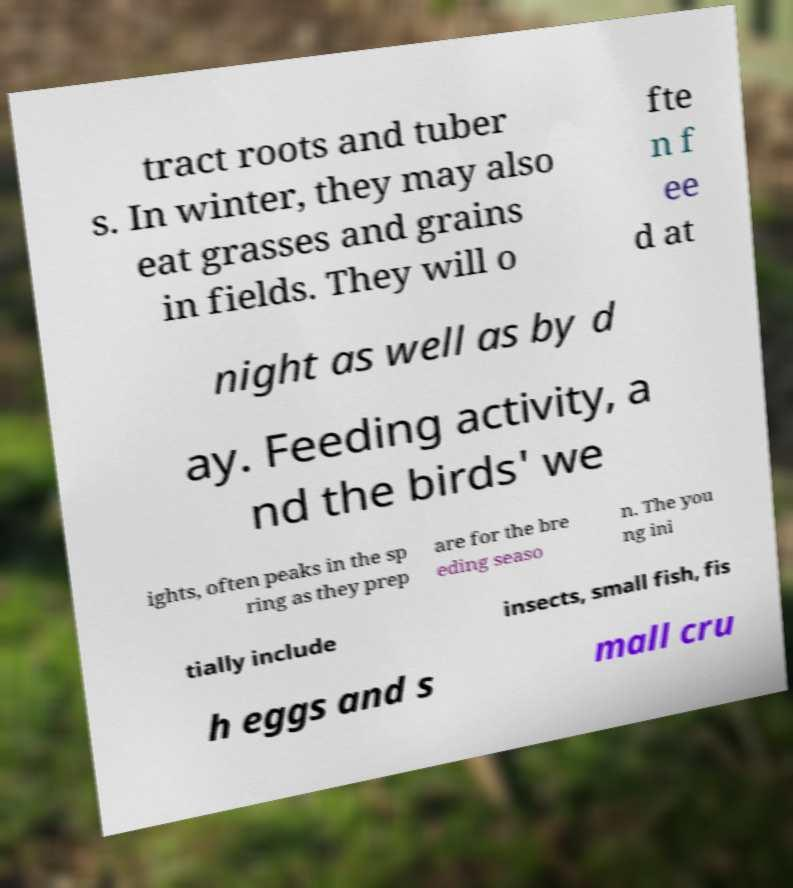What messages or text are displayed in this image? I need them in a readable, typed format. tract roots and tuber s. In winter, they may also eat grasses and grains in fields. They will o fte n f ee d at night as well as by d ay. Feeding activity, a nd the birds' we ights, often peaks in the sp ring as they prep are for the bre eding seaso n. The you ng ini tially include insects, small fish, fis h eggs and s mall cru 